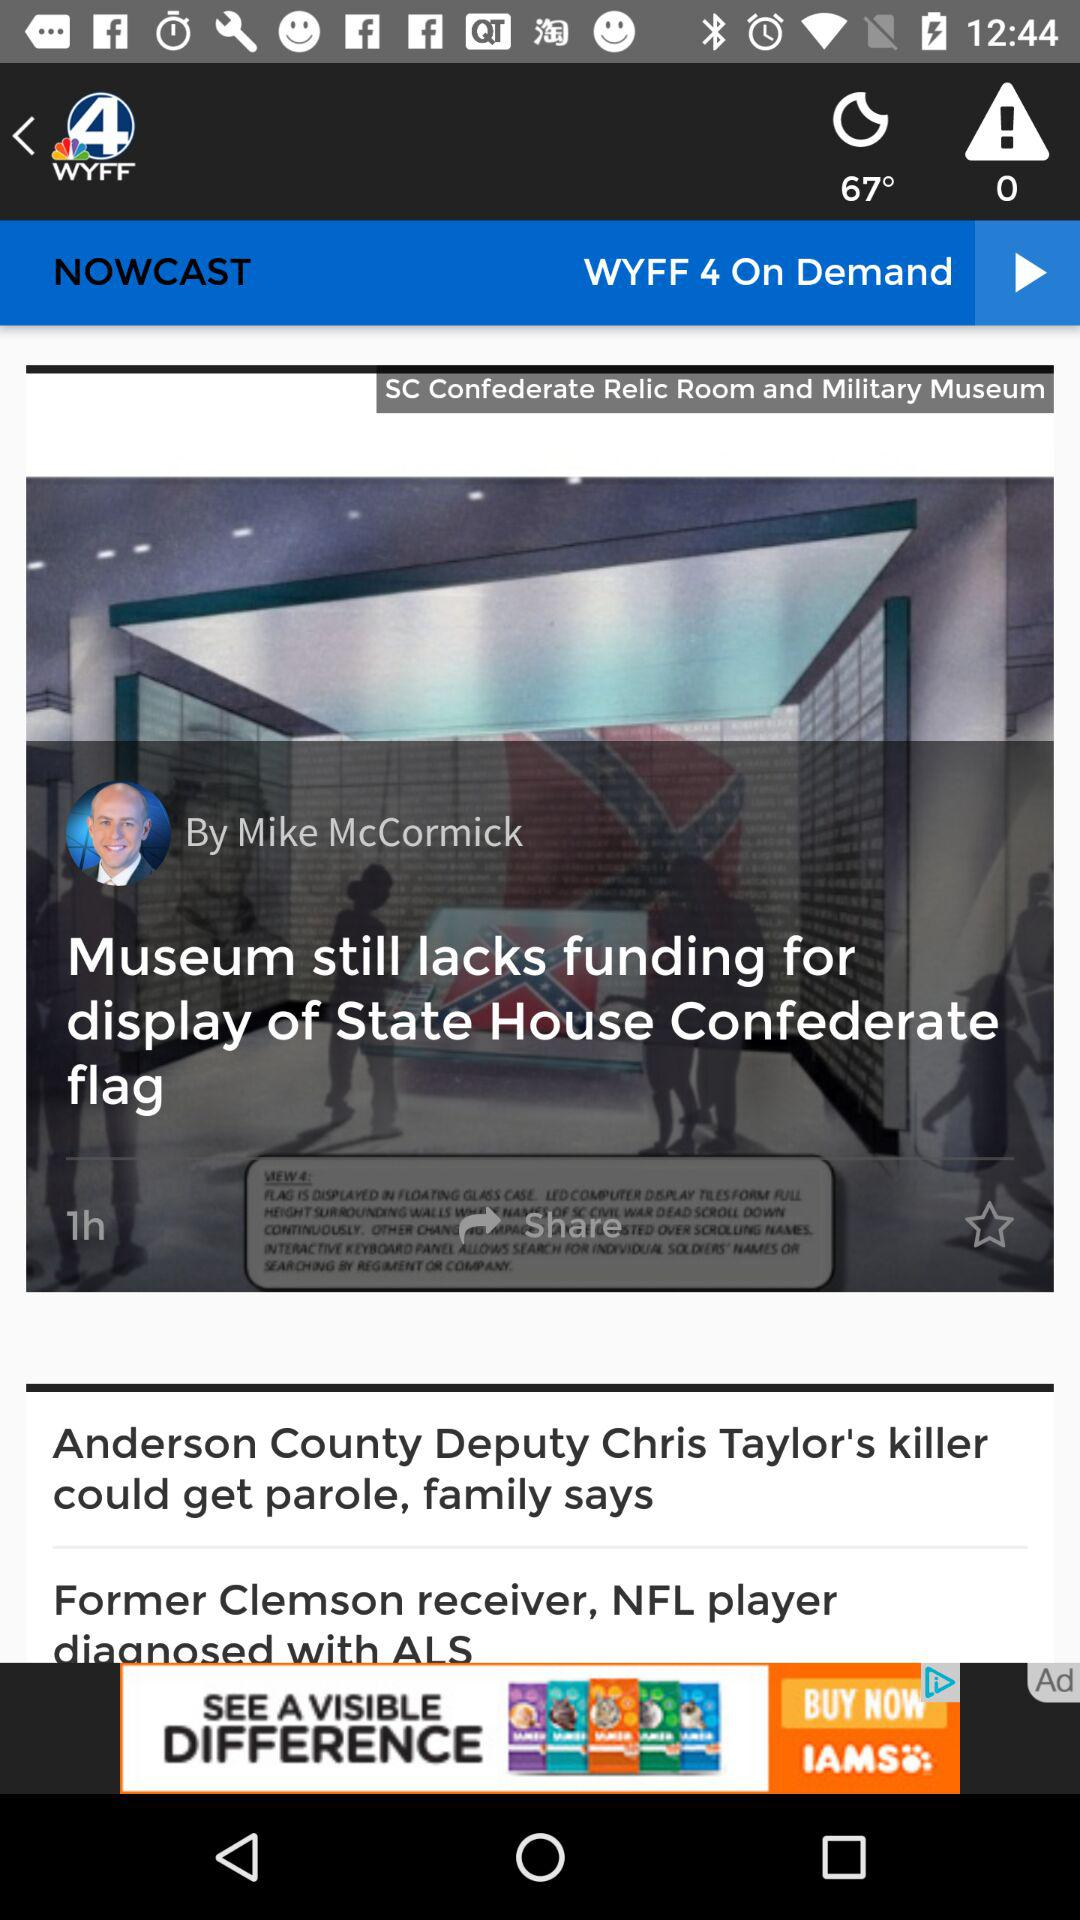When was the news published? The news was published one hour ago. 